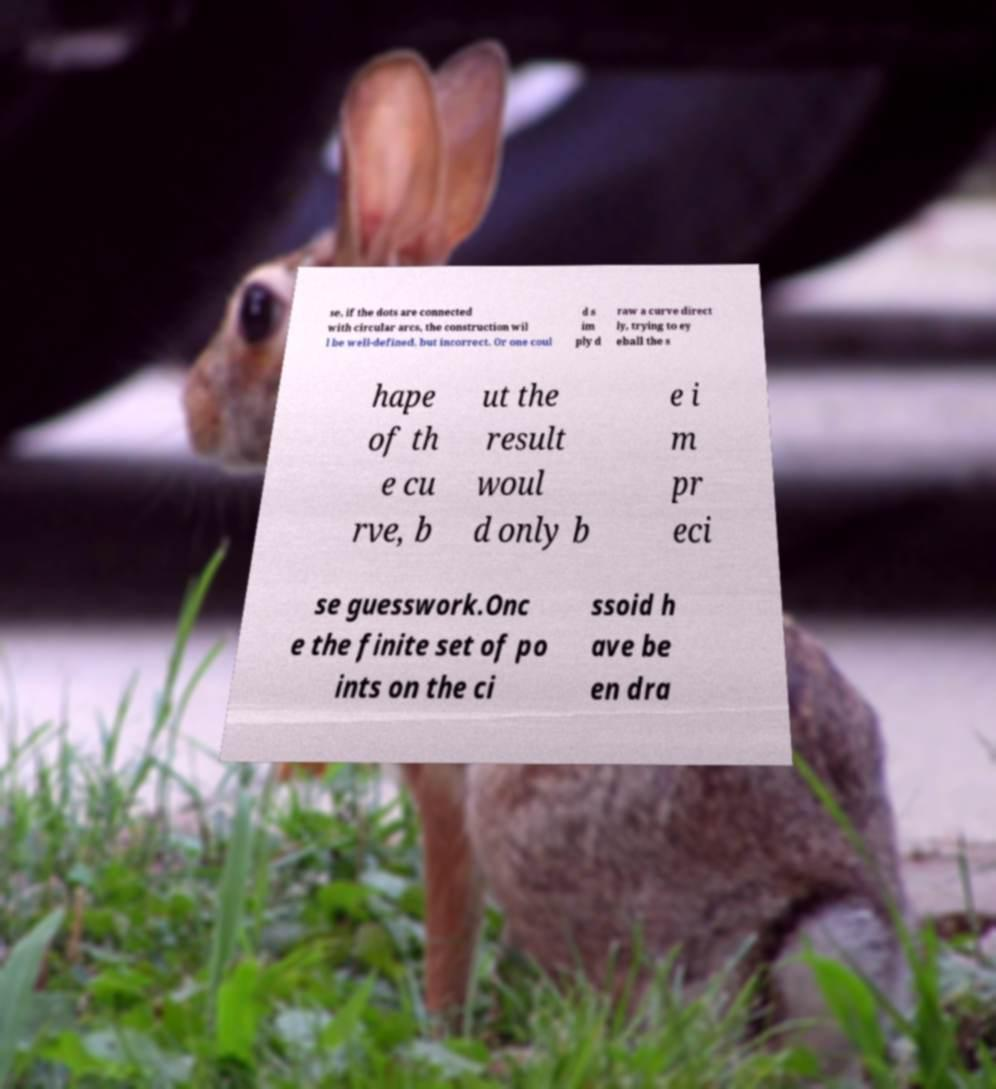Can you accurately transcribe the text from the provided image for me? se, if the dots are connected with circular arcs, the construction wil l be well-defined, but incorrect. Or one coul d s im ply d raw a curve direct ly, trying to ey eball the s hape of th e cu rve, b ut the result woul d only b e i m pr eci se guesswork.Onc e the finite set of po ints on the ci ssoid h ave be en dra 